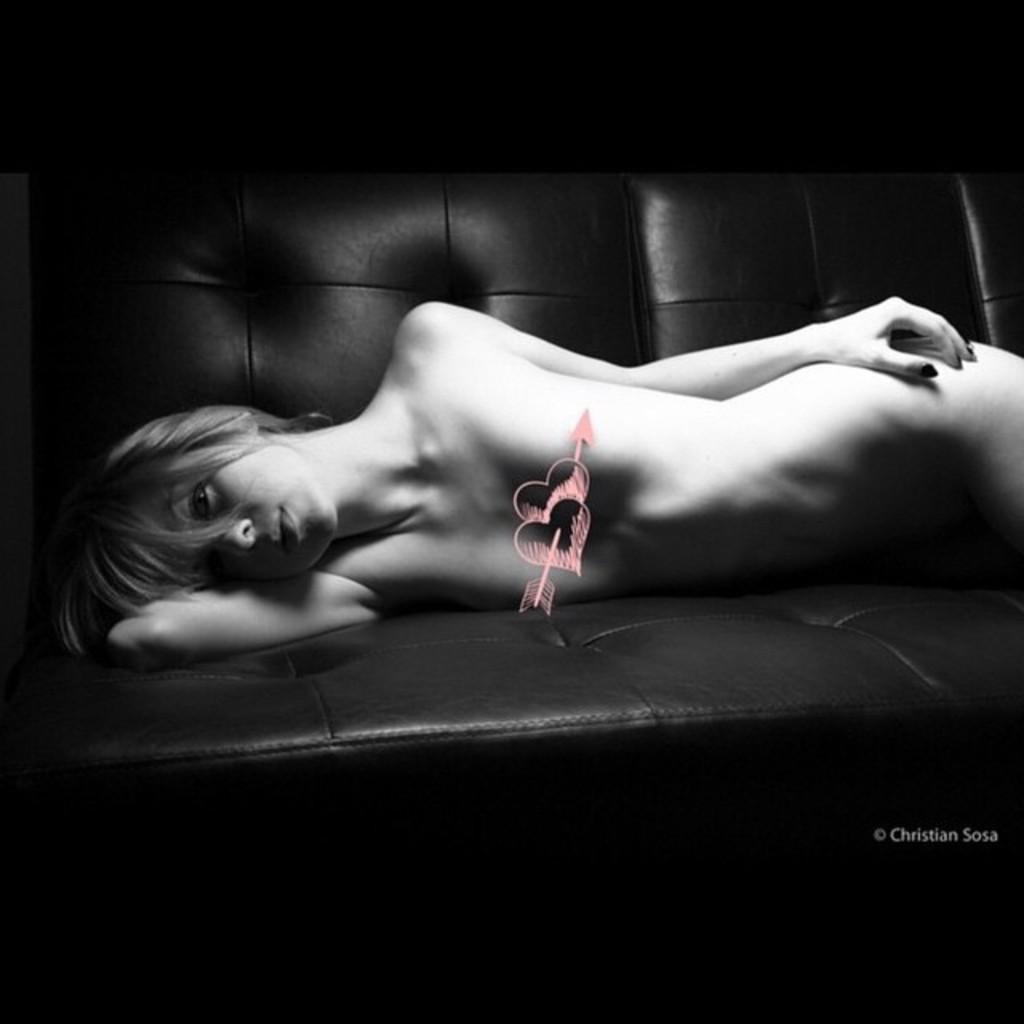How would you summarize this image in a sentence or two? In this image there is a woman lying naked on the sofa bed. 